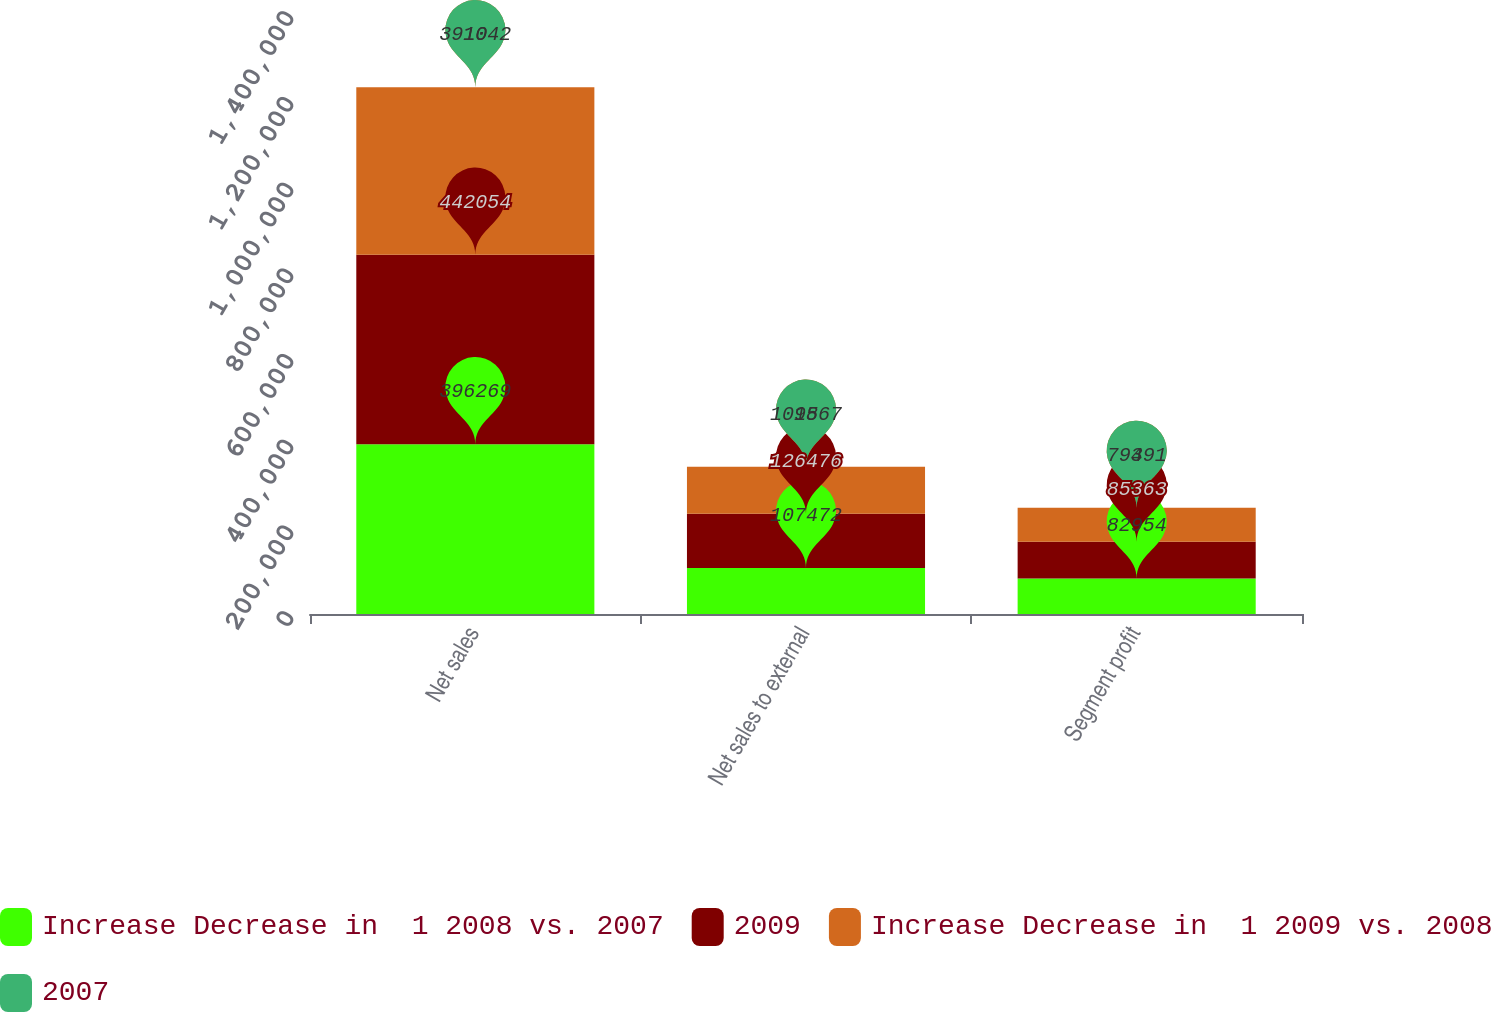<chart> <loc_0><loc_0><loc_500><loc_500><stacked_bar_chart><ecel><fcel>Net sales<fcel>Net sales to external<fcel>Segment profit<nl><fcel>Increase Decrease in  1 2008 vs. 2007<fcel>396269<fcel>107472<fcel>82954<nl><fcel>2009<fcel>442054<fcel>126476<fcel>85363<nl><fcel>Increase Decrease in  1 2009 vs. 2008<fcel>391042<fcel>109867<fcel>79491<nl><fcel>2007<fcel>10<fcel>15<fcel>3<nl></chart> 